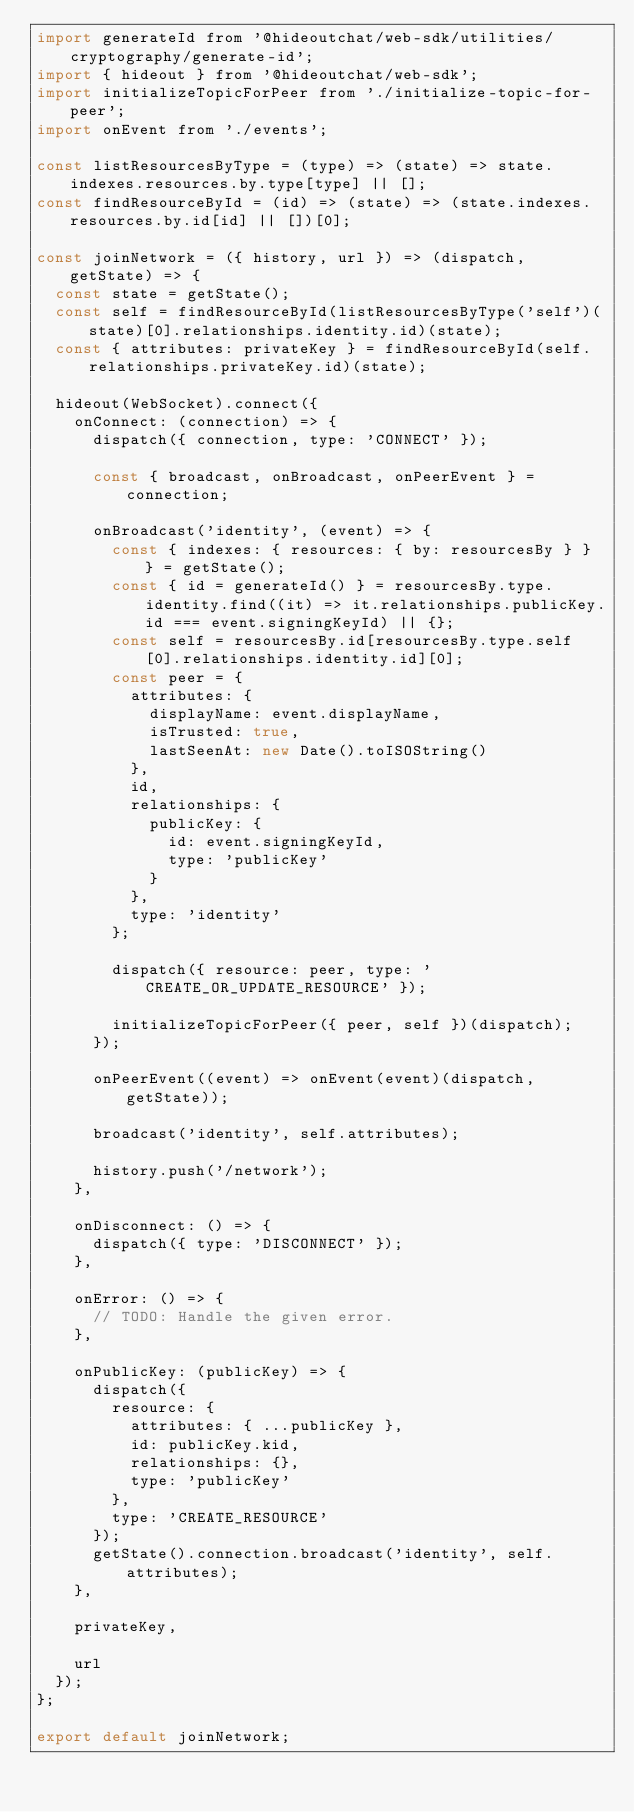Convert code to text. <code><loc_0><loc_0><loc_500><loc_500><_JavaScript_>import generateId from '@hideoutchat/web-sdk/utilities/cryptography/generate-id';
import { hideout } from '@hideoutchat/web-sdk';
import initializeTopicForPeer from './initialize-topic-for-peer';
import onEvent from './events';

const listResourcesByType = (type) => (state) => state.indexes.resources.by.type[type] || [];
const findResourceById = (id) => (state) => (state.indexes.resources.by.id[id] || [])[0];

const joinNetwork = ({ history, url }) => (dispatch, getState) => {
  const state = getState();
  const self = findResourceById(listResourcesByType('self')(state)[0].relationships.identity.id)(state);
  const { attributes: privateKey } = findResourceById(self.relationships.privateKey.id)(state);

  hideout(WebSocket).connect({
    onConnect: (connection) => {
      dispatch({ connection, type: 'CONNECT' });

      const { broadcast, onBroadcast, onPeerEvent } = connection;

      onBroadcast('identity', (event) => {
        const { indexes: { resources: { by: resourcesBy } } } = getState();
        const { id = generateId() } = resourcesBy.type.identity.find((it) => it.relationships.publicKey.id === event.signingKeyId) || {};
        const self = resourcesBy.id[resourcesBy.type.self[0].relationships.identity.id][0];
        const peer = {
          attributes: {
            displayName: event.displayName,
            isTrusted: true,
            lastSeenAt: new Date().toISOString()
          },
          id,
          relationships: {
            publicKey: {
              id: event.signingKeyId,
              type: 'publicKey'
            }
          },
          type: 'identity'
        };

        dispatch({ resource: peer, type: 'CREATE_OR_UPDATE_RESOURCE' });

        initializeTopicForPeer({ peer, self })(dispatch);
      });

      onPeerEvent((event) => onEvent(event)(dispatch, getState));

      broadcast('identity', self.attributes);

      history.push('/network');
    },

    onDisconnect: () => {
      dispatch({ type: 'DISCONNECT' });
    },

    onError: () => {
      // TODO: Handle the given error.
    },

    onPublicKey: (publicKey) => {
      dispatch({
        resource: {
          attributes: { ...publicKey },
          id: publicKey.kid,
          relationships: {},
          type: 'publicKey'
        },
        type: 'CREATE_RESOURCE'
      });
      getState().connection.broadcast('identity', self.attributes);
    },

    privateKey,

    url
  });
};

export default joinNetwork;
</code> 